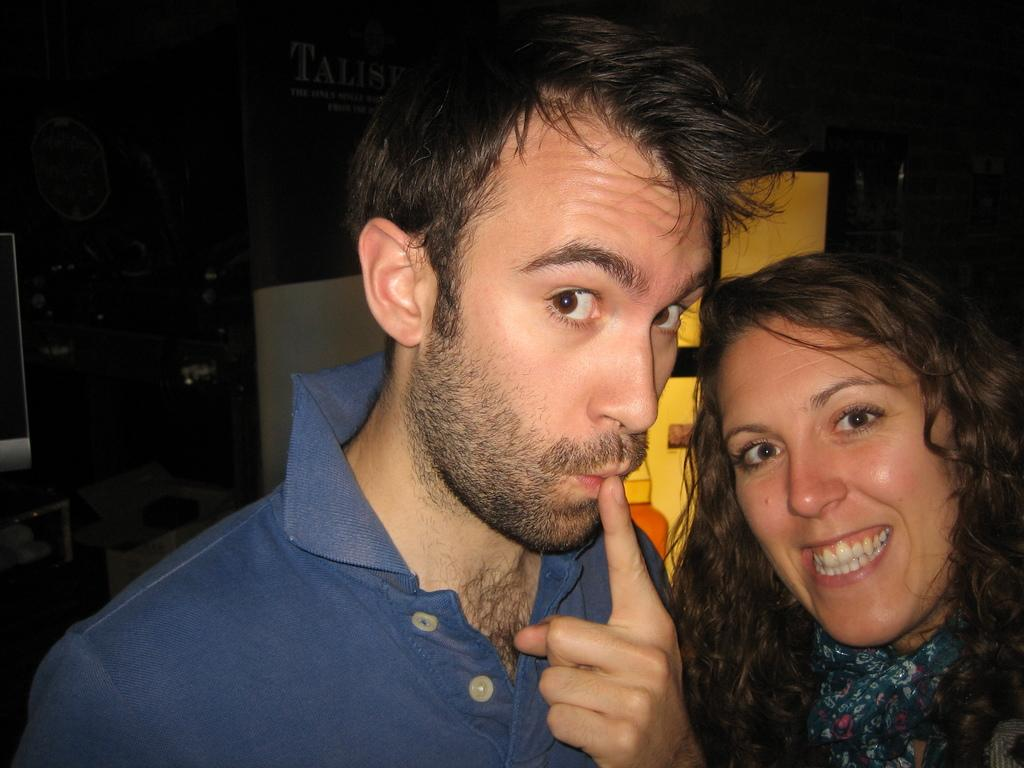How many people are in the image? There are two people in the image, a man and a woman. What are the man and woman doing in the image? The man and woman are standing together. What is the expression on the woman's face? The woman is smiling. What is the man doing with his finger in the image? The man has his finger on his mouth. Can you describe the background of the image? The background of the image is not clear. What type of mass is the man holding in the image? There is no mass present in the image; the man has his finger on his mouth. What is the woman using to perform addition in the image? There is no addition or any related tools present in the image. 